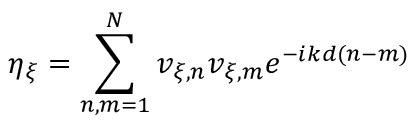Convert formula to latex. <formula><loc_0><loc_0><loc_500><loc_500>\eta _ { \xi } = \sum _ { n , m = 1 } ^ { N } v _ { \xi , n } v _ { \xi , m } e ^ { - i k d ( n - m ) }</formula> 